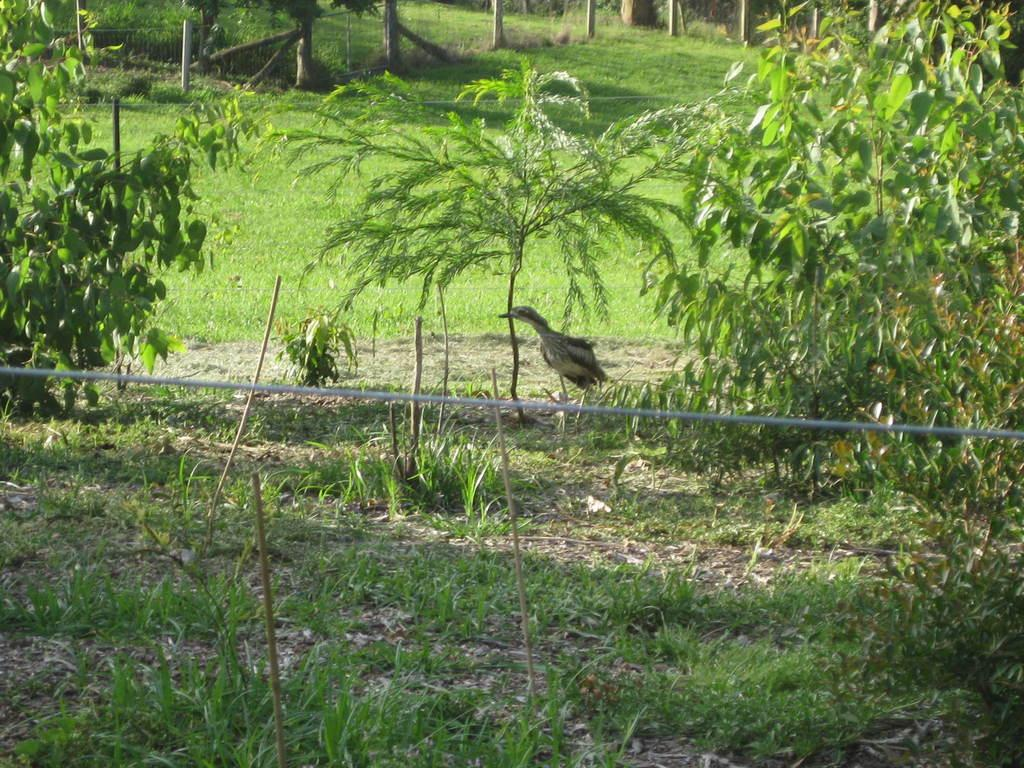What type of vegetation can be seen in the image? There is grass and plants in the image. What type of animal is present in the image? There is a bird in the image. What type of fruit is the bird holding in the image? There is no fruit present in the image, and the bird is not holding anything. Can you tell me how many firemen are visible in the image? There are no firemen present in the image. 